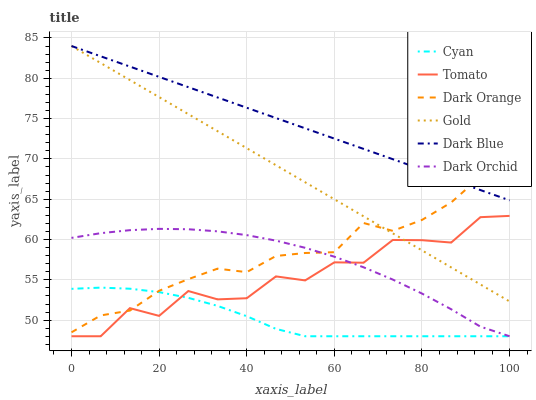Does Cyan have the minimum area under the curve?
Answer yes or no. Yes. Does Dark Blue have the maximum area under the curve?
Answer yes or no. Yes. Does Dark Orange have the minimum area under the curve?
Answer yes or no. No. Does Dark Orange have the maximum area under the curve?
Answer yes or no. No. Is Dark Blue the smoothest?
Answer yes or no. Yes. Is Tomato the roughest?
Answer yes or no. Yes. Is Dark Orange the smoothest?
Answer yes or no. No. Is Dark Orange the roughest?
Answer yes or no. No. Does Dark Orange have the lowest value?
Answer yes or no. No. Does Dark Blue have the highest value?
Answer yes or no. Yes. Does Dark Orange have the highest value?
Answer yes or no. No. Is Dark Orchid less than Gold?
Answer yes or no. Yes. Is Gold greater than Cyan?
Answer yes or no. Yes. Does Tomato intersect Cyan?
Answer yes or no. Yes. Is Tomato less than Cyan?
Answer yes or no. No. Is Tomato greater than Cyan?
Answer yes or no. No. Does Dark Orchid intersect Gold?
Answer yes or no. No. 